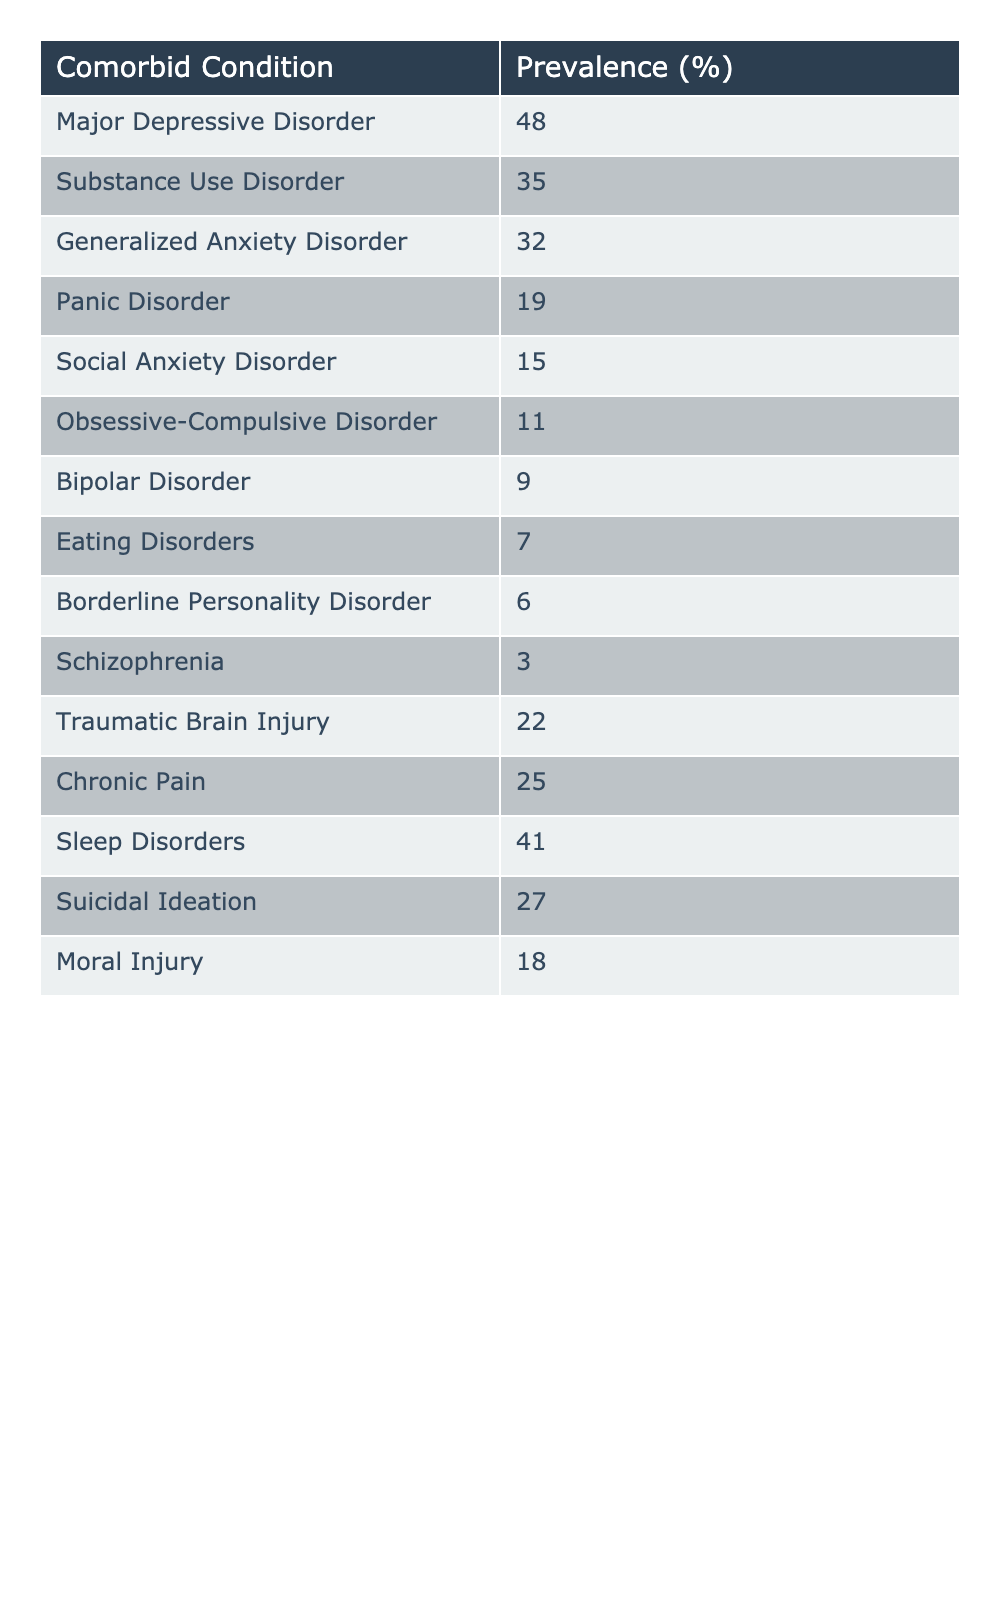What is the prevalence of Major Depressive Disorder among veterans with PTSD? The table shows that the prevalence of Major Depressive Disorder is listed as 48%.
Answer: 48% Which comorbid condition has the lowest prevalence in veterans with PTSD? The table indicates that Schizophrenia has the lowest prevalence at 3%.
Answer: 3% What is the prevalence of Sleep Disorders in relation to Substance Use Disorder? Sleep Disorders have a prevalence of 41%, while Substance Use Disorder has a prevalence of 35%. Therefore, Sleep Disorders are more prevalent by 6%.
Answer: 6% How many comorbid conditions have a prevalence of 20% or higher? By examining the table, we see that 8 conditions have prevalence values of 20% or higher: Major Depressive Disorder, Substance Use Disorder, Generalized Anxiety Disorder, Traumatic Brain Injury, Chronic Pain, and Sleep Disorders along with two others: Panic Disorder (19%) and Suicidal Ideation (27%). Hence, the total is 6.
Answer: 6 Is the prevalence of Anxiety Disorders overall greater than 50% when combining Generalized Anxiety Disorder, Panic Disorder, and Social Anxiety Disorder? Summing their prevalences: Generalized Anxiety Disorder (32%) + Panic Disorder (19%) + Social Anxiety Disorder (15%) equals 66%. Therefore, the total is greater than 50%.
Answer: Yes What is the difference in prevalence between Chronic Pain and Major Depressive Disorder? The table shows that Chronic Pain has a prevalence of 25% and Major Depressive Disorder has a prevalence of 48%. The difference is 48% - 25% = 23%.
Answer: 23% Are there any comorbid conditions with a prevalence of exactly 15%? The table indicates that Social Anxiety Disorder has a prevalence of exactly 15%.
Answer: Yes What is the total prevalence of the conditions characterized as having 'Trauma-related' aspects, such as PTSD itself? The conditions falling into trauma-related categories, excluding the main PTSD category, are Moral Injury (18%) and Traumatic Brain Injury (22%). Therefore, the total is 18% + 22% = 40%.
Answer: 40% Which two comorbid conditions have a combined prevalence closest to 50%? By checking the prevalent values, Major Depressive Disorder (48%) and Borderline Personality Disorder (6%) total to 54%, which is the closest pair without exceeding 50%.
Answer: 54% What percentage of veterans with PTSD experience either Suicidal Ideation or Moral Injury? Adding Suicidal Ideation (27%) and Moral Injury (18%) gives us 27% + 18% = 45%.
Answer: 45% Calculate the average prevalence of the conditions listed in the table. To find the average, first add the percentages: 48 + 35 + 32 + 19 + 15 + 11 + 9 + 7 + 6 + 3 + 22 + 25 + 41 + 27 + 18 =  399. There are 15 conditions, thus, the average is 399 / 15 = 26.6%.
Answer: 26.6% 